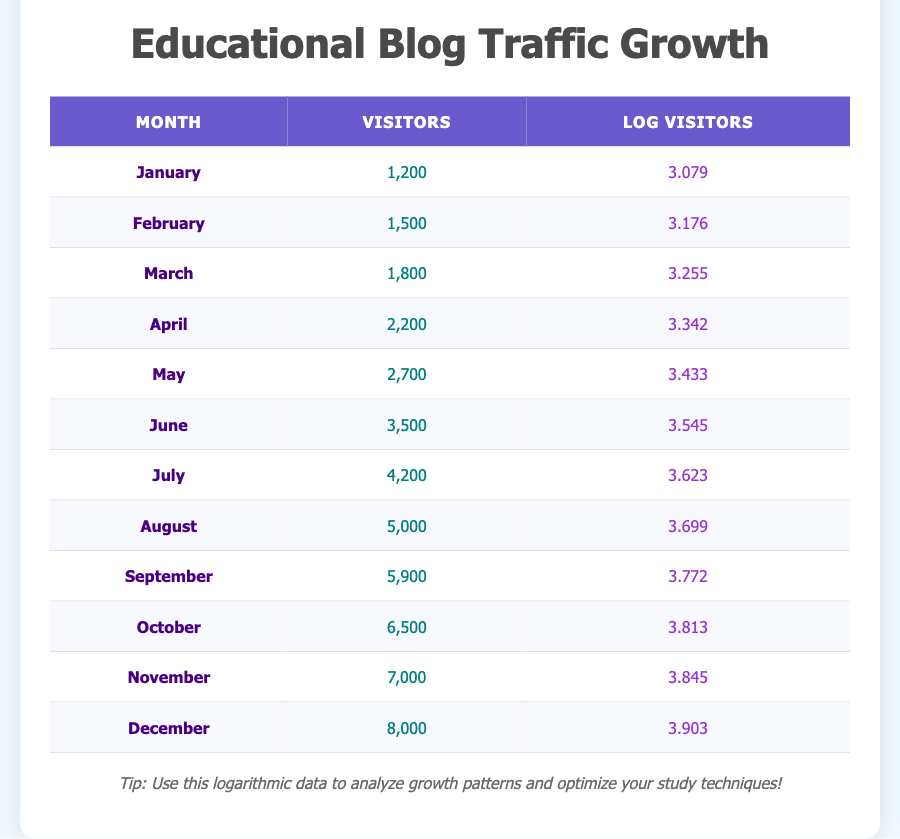What was the highest number of visitors recorded in a single month? The table lists the number of visitors for each month. By scanning through the "Visitors" column, we find that December has the highest value at 8000 visitors.
Answer: 8000 In which month did the website traffic first exceed 5000 visitors? Looking at the "Visitors" column, we see that August has 5000 visitors and September has 5900 visitors. Therefore, the first month to exceed 5000 visitors is September.
Answer: September What is the average number of visitors from January to June? First, we calculate the total number of visitors for the first six months: 1200 + 1500 + 1800 + 2200 + 2700 + 3500 = 12900. Then, we divide this total by 6 (the number of months): 12900 / 6 = 2150.
Answer: 2150 True or false: The number of visitors increased every month. By reviewing the "Visitors" column for each month, it is clear that the number of visitors consistently increases without any decreases throughout the year.
Answer: True How much did the visitor count increase from June to December? The number of visitors in June is 3500 and in December it is 8000. To find the increase, we subtract June's count from December's: 8000 - 3500 = 4500.
Answer: 4500 What is the logarithmic value of the visitors in November? The "Log Visitors" column indicates that the value for November is listed as 3.845.
Answer: 3.845 Which month had the smallest growth in visitors compared to the previous month? By examining the differences in visitor counts between consecutive months: January (1200) to February (1500) gives an increase of 300; February to March gives 300; March to April gives 400; April to May gives 500; May to June gives 800; June to July gives 700; July to August gives 800; August to September gives 900; September to October gives 600; October to November gives 500; and November to December gives 1000. The smallest increase is 300, occurring between January and February or February and March.
Answer: January-February or February-March If we were to plot the logarithmic values, what trend would we observe? The "Log Visitors" values consistently increase month-to-month, indicating a steady growth trend when visualized on a graph over the 12 months.
Answer: Steady growth trend 